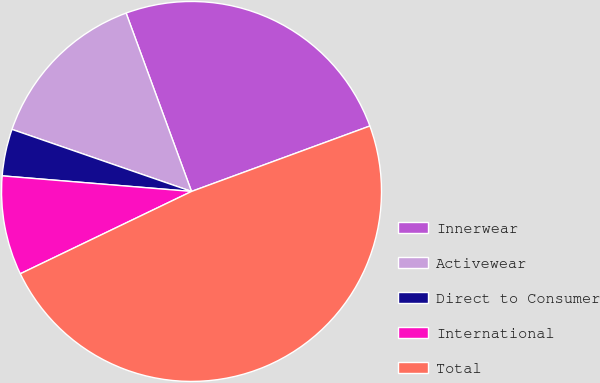<chart> <loc_0><loc_0><loc_500><loc_500><pie_chart><fcel>Innerwear<fcel>Activewear<fcel>Direct to Consumer<fcel>International<fcel>Total<nl><fcel>25.0%<fcel>14.11%<fcel>3.99%<fcel>8.44%<fcel>48.47%<nl></chart> 